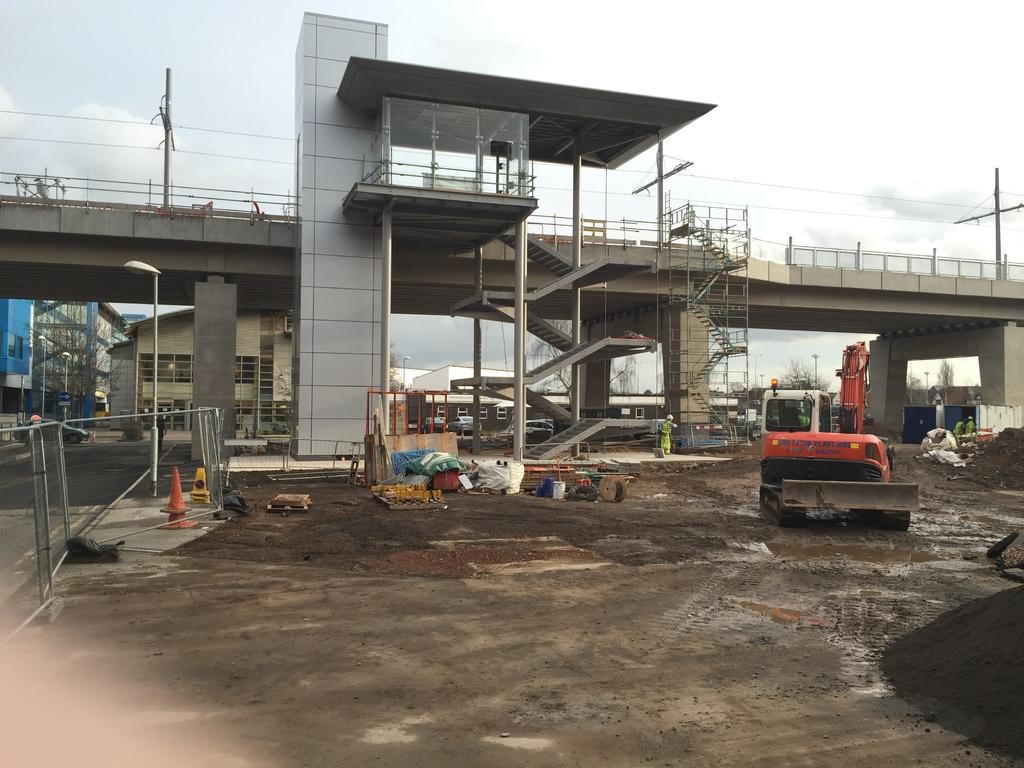What is the main subject of the image? There is a vehicle in the image. Where is the vehicle located? The vehicle is on the ground. What can be seen in the background of the image? There are buildings, trees, poles, and the sky visible in the background of the image. What type of error can be seen on the vehicle in the image? There is no error visible on the vehicle in the image. Can you see any feathers falling from the sky in the image? There are no feathers present in the image; only the vehicle, buildings, trees, poles, and sky are visible. 